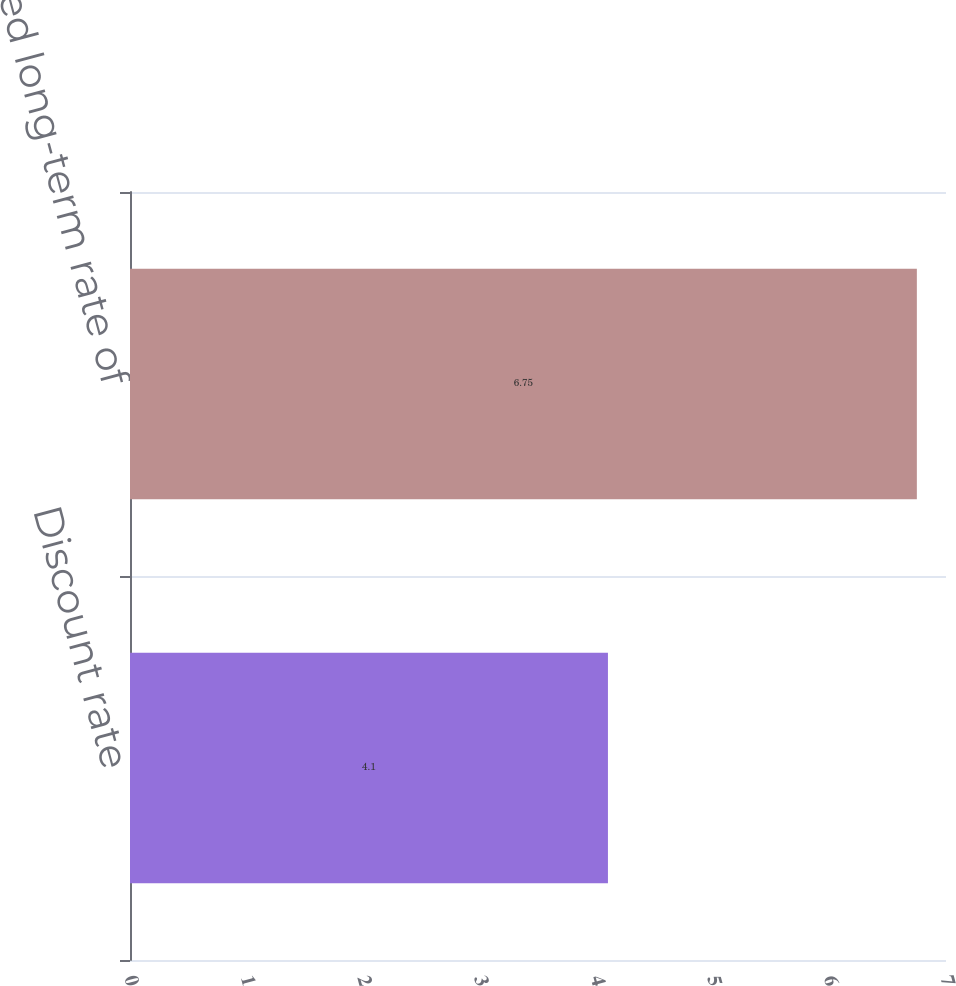<chart> <loc_0><loc_0><loc_500><loc_500><bar_chart><fcel>Discount rate<fcel>Expected long-term rate of<nl><fcel>4.1<fcel>6.75<nl></chart> 